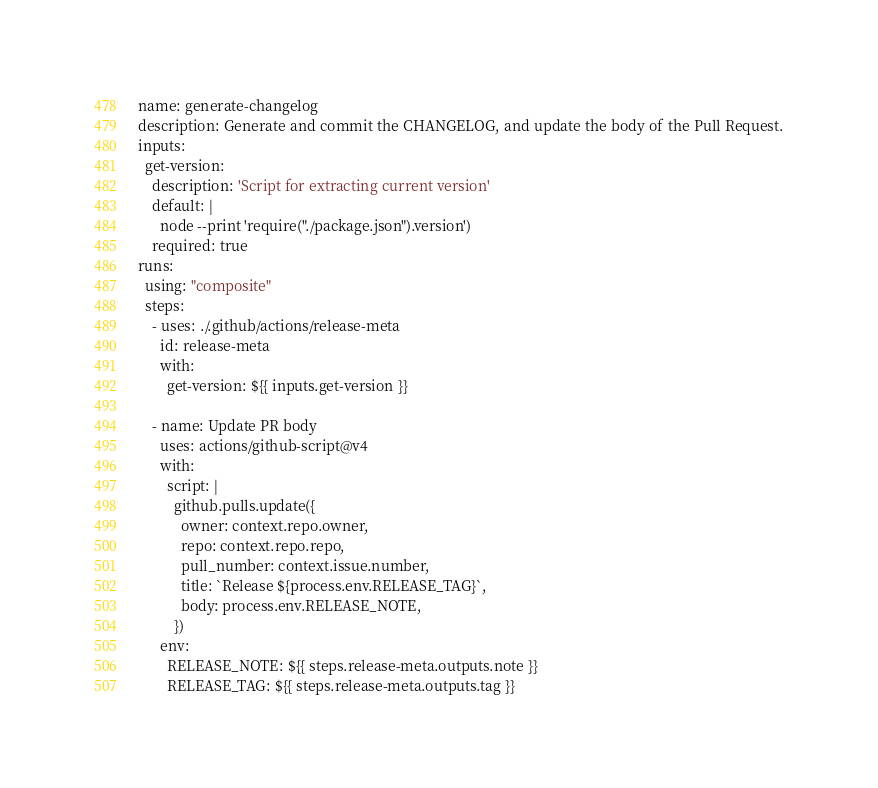Convert code to text. <code><loc_0><loc_0><loc_500><loc_500><_YAML_>name: generate-changelog
description: Generate and commit the CHANGELOG, and update the body of the Pull Request.
inputs:
  get-version:
    description: 'Script for extracting current version'
    default: |
      node --print 'require("./package.json").version')
    required: true
runs:
  using: "composite"
  steps:
    - uses: ./.github/actions/release-meta
      id: release-meta
      with:
        get-version: ${{ inputs.get-version }}

    - name: Update PR body
      uses: actions/github-script@v4
      with:
        script: |
          github.pulls.update({
            owner: context.repo.owner,
            repo: context.repo.repo,
            pull_number: context.issue.number,
            title: `Release ${process.env.RELEASE_TAG}`,
            body: process.env.RELEASE_NOTE,
          })
      env:
        RELEASE_NOTE: ${{ steps.release-meta.outputs.note }}
        RELEASE_TAG: ${{ steps.release-meta.outputs.tag }}
</code> 